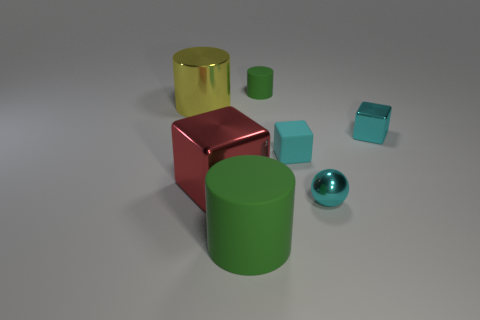There is a big object that is the same color as the small cylinder; what material is it?
Give a very brief answer. Rubber. Does the rubber block have the same size as the green rubber thing behind the large matte cylinder?
Make the answer very short. Yes. Are there any small shiny balls of the same color as the tiny rubber cube?
Your answer should be compact. Yes. Are there any red rubber objects of the same shape as the large yellow object?
Your answer should be very brief. No. What is the shape of the metal thing that is behind the tiny shiny ball and on the right side of the red shiny block?
Make the answer very short. Cube. How many green cylinders are the same material as the big yellow thing?
Your response must be concise. 0. Are there fewer cylinders behind the cyan metal sphere than cyan spheres?
Offer a very short reply. No. There is a cyan metal thing that is in front of the tiny cyan shiny block; is there a cyan thing to the right of it?
Provide a short and direct response. Yes. Is there any other thing that is the same shape as the tiny green rubber object?
Offer a very short reply. Yes. Is the red metal object the same size as the cyan ball?
Offer a very short reply. No. 